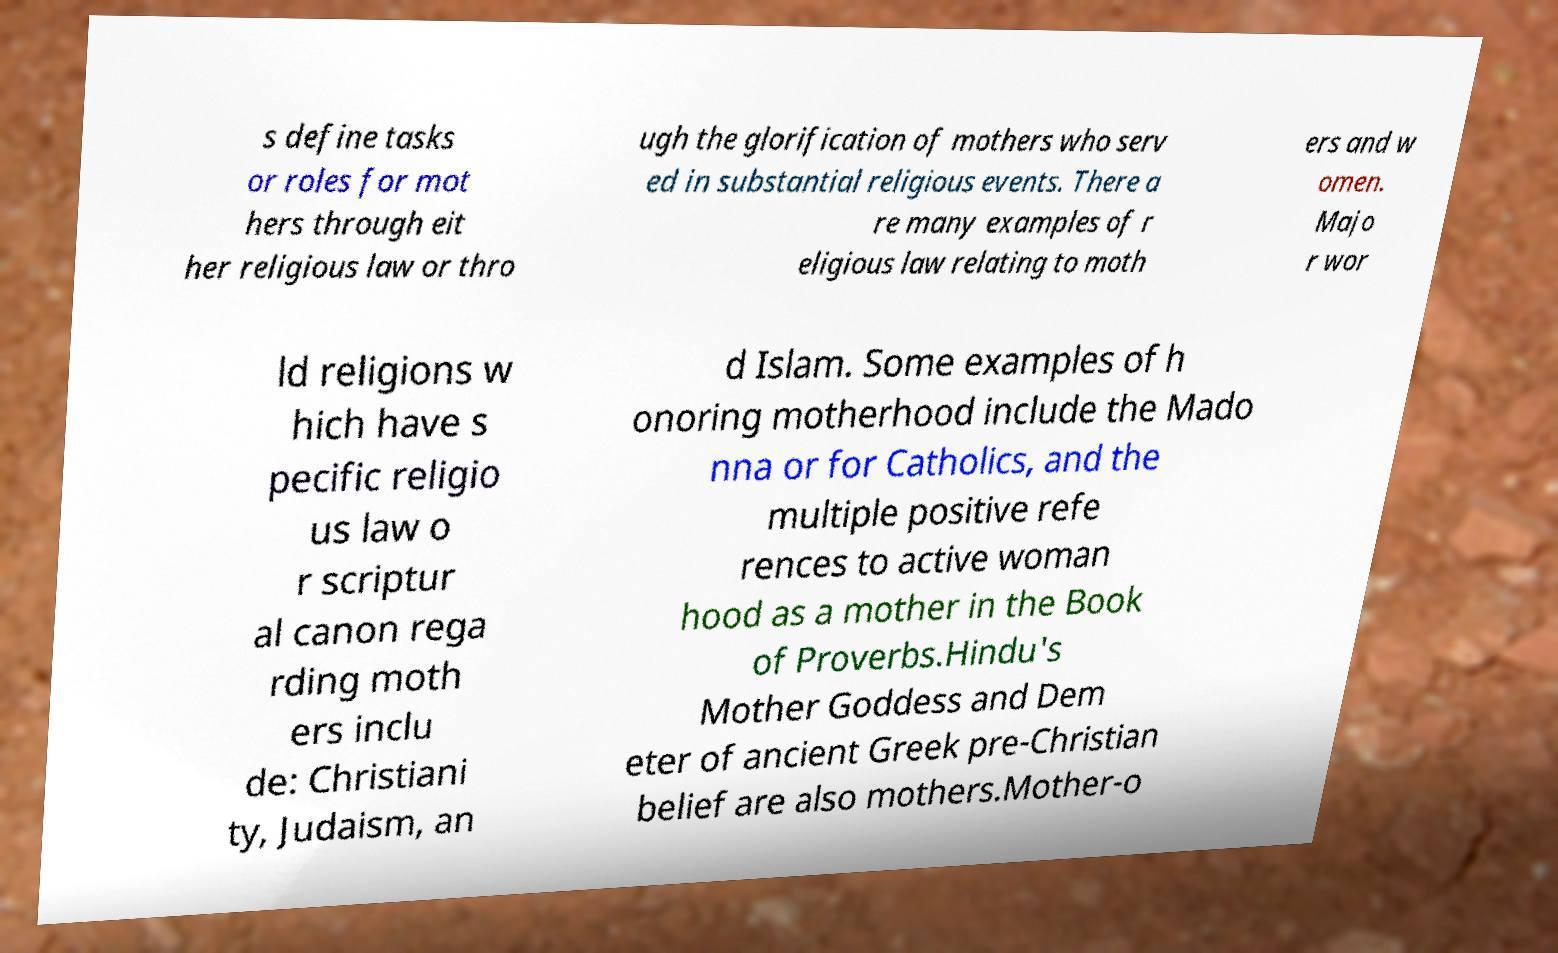Could you extract and type out the text from this image? s define tasks or roles for mot hers through eit her religious law or thro ugh the glorification of mothers who serv ed in substantial religious events. There a re many examples of r eligious law relating to moth ers and w omen. Majo r wor ld religions w hich have s pecific religio us law o r scriptur al canon rega rding moth ers inclu de: Christiani ty, Judaism, an d Islam. Some examples of h onoring motherhood include the Mado nna or for Catholics, and the multiple positive refe rences to active woman hood as a mother in the Book of Proverbs.Hindu's Mother Goddess and Dem eter of ancient Greek pre-Christian belief are also mothers.Mother-o 